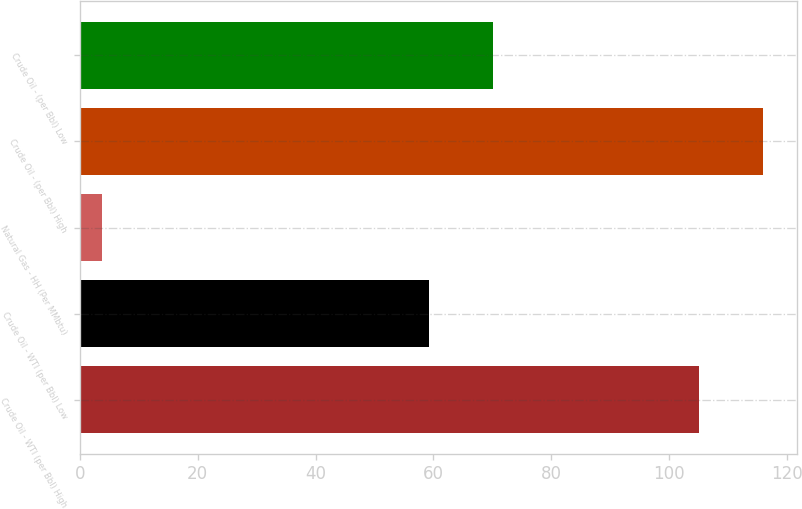Convert chart. <chart><loc_0><loc_0><loc_500><loc_500><bar_chart><fcel>Crude Oil - WTI (per Bbl) High<fcel>Crude Oil - WTI (per Bbl) Low<fcel>Natural Gas - HH (Per MMbtu)<fcel>Crude Oil - (per Bbl) High<fcel>Crude Oil - (per Bbl) Low<nl><fcel>105.15<fcel>59.29<fcel>3.73<fcel>115.95<fcel>70.09<nl></chart> 